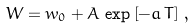Convert formula to latex. <formula><loc_0><loc_0><loc_500><loc_500>W = w _ { 0 } + A \, \exp \left [ - a \, T \right ] \, ,</formula> 